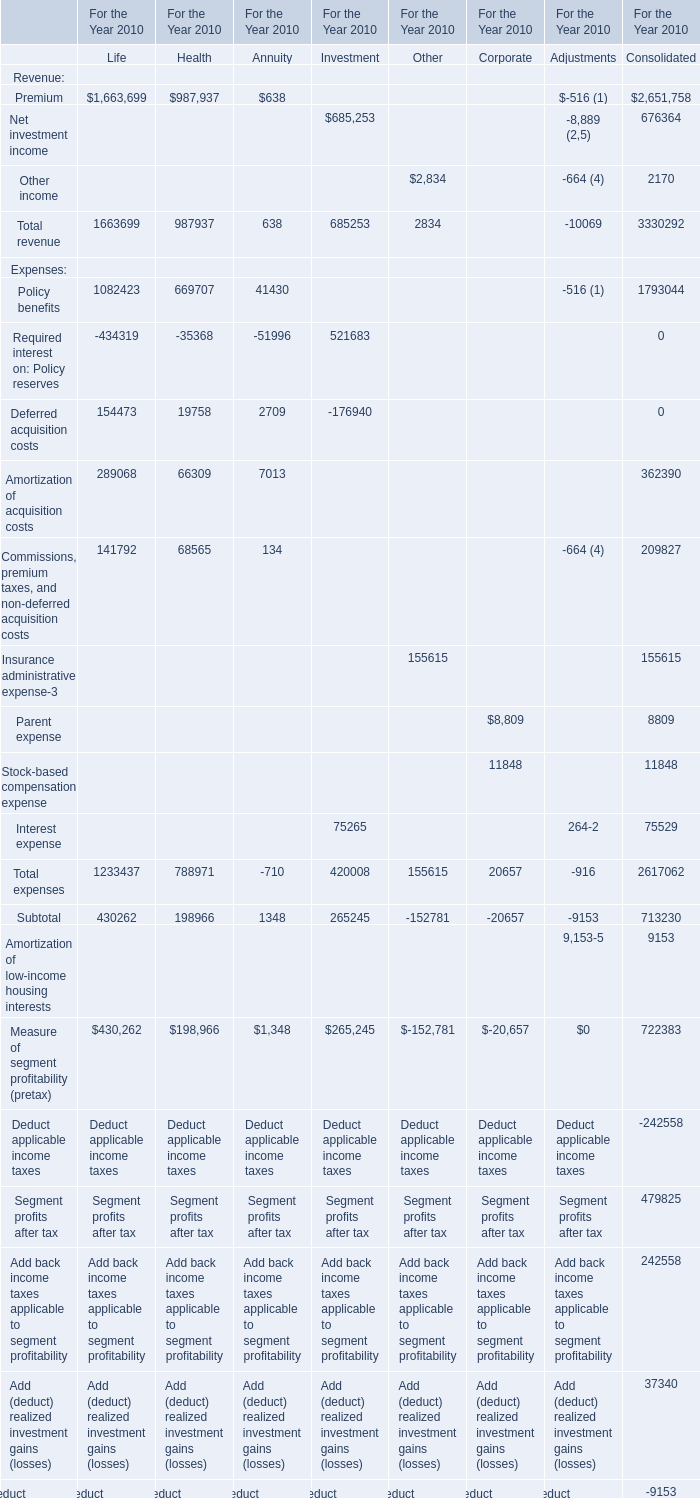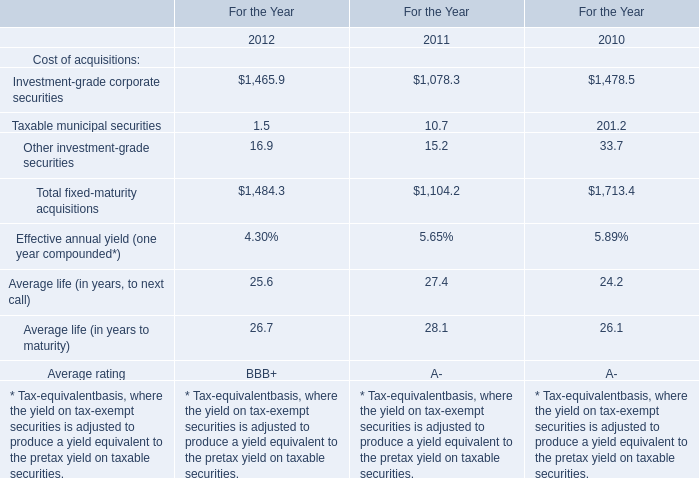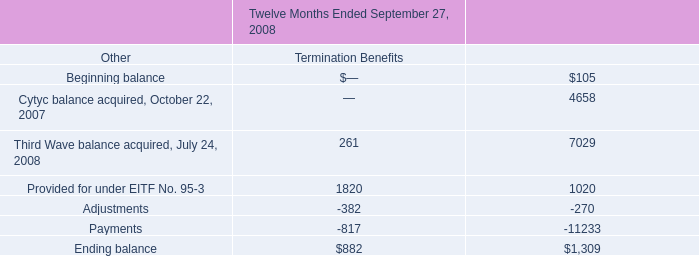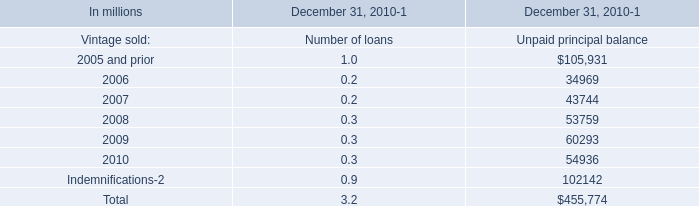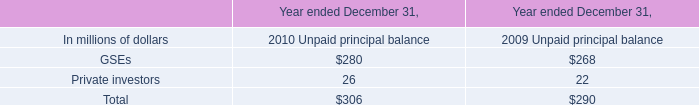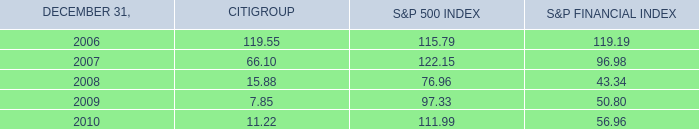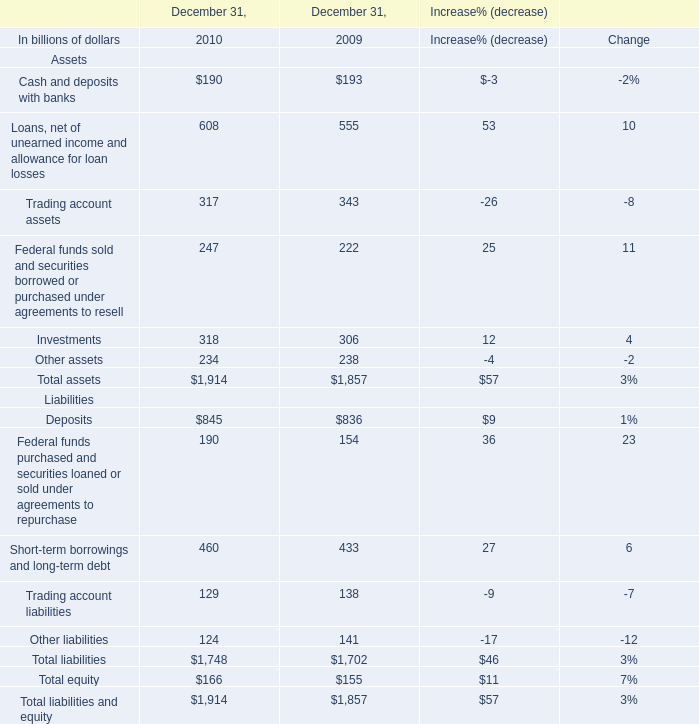what is the growth rate in advertising costs from 2007 to 2008? 
Computations: ((15281 - 6683) / 6683)
Answer: 1.28655. 